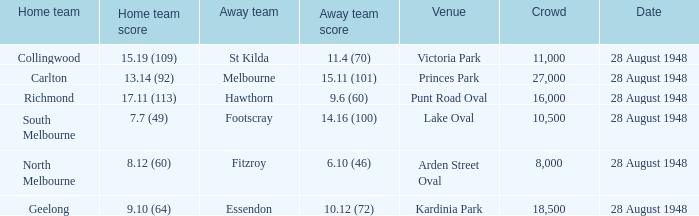What is the point total for the st kilda away team? 11.4 (70). 